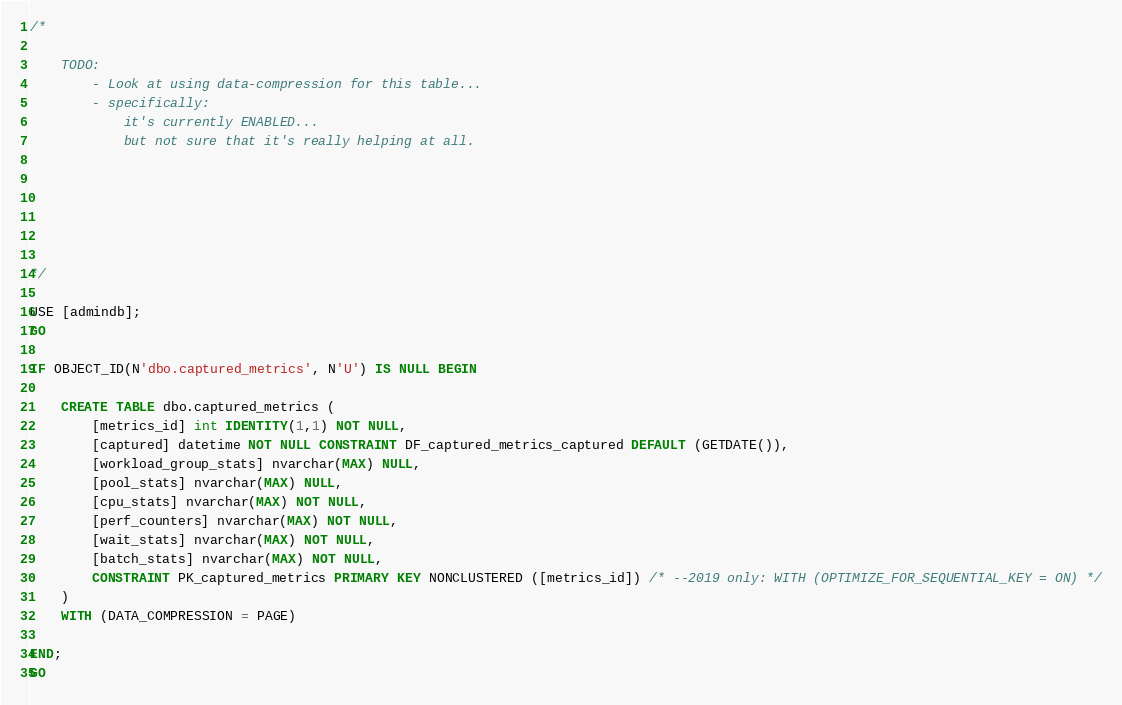<code> <loc_0><loc_0><loc_500><loc_500><_SQL_>/*

	TODO: 
		- Look at using data-compression for this table... 
		- specifically: 
			it's currently ENABLED... 
			but not sure that it's really helping at all. 






*/

USE [admindb];
GO

IF OBJECT_ID(N'dbo.captured_metrics', N'U') IS NULL BEGIN 

	CREATE TABLE dbo.captured_metrics (
		[metrics_id] int IDENTITY(1,1) NOT NULL, 
		[captured] datetime NOT NULL CONSTRAINT DF_captured_metrics_captured DEFAULT (GETDATE()), 
		[workload_group_stats] nvarchar(MAX) NULL, 
		[pool_stats] nvarchar(MAX) NULL, 
		[cpu_stats] nvarchar(MAX) NOT NULL, 
		[perf_counters] nvarchar(MAX) NOT NULL, 
		[wait_stats] nvarchar(MAX) NOT NULL,
		[batch_stats] nvarchar(MAX) NOT NULL, 
		CONSTRAINT PK_captured_metrics PRIMARY KEY NONCLUSTERED ([metrics_id]) /* --2019 only: WITH (OPTIMIZE_FOR_SEQUENTIAL_KEY = ON) */
	)
	WITH (DATA_COMPRESSION = PAGE)

END;
GO</code> 